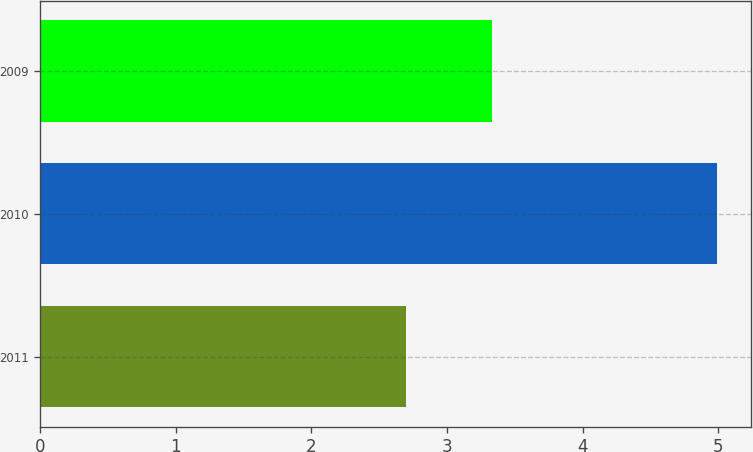Convert chart. <chart><loc_0><loc_0><loc_500><loc_500><bar_chart><fcel>2011<fcel>2010<fcel>2009<nl><fcel>2.7<fcel>4.99<fcel>3.33<nl></chart> 